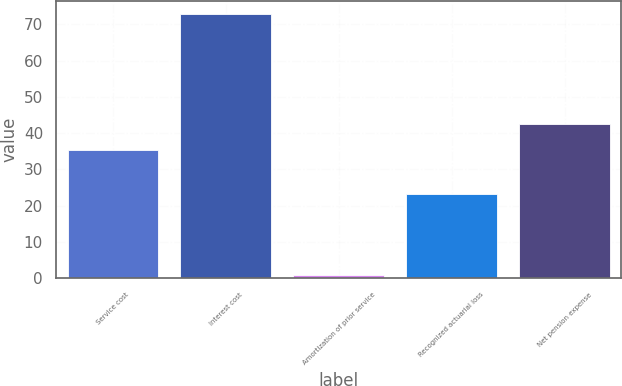Convert chart. <chart><loc_0><loc_0><loc_500><loc_500><bar_chart><fcel>Service cost<fcel>Interest cost<fcel>Amortization of prior service<fcel>Recognized actuarial loss<fcel>Net pension expense<nl><fcel>35.3<fcel>72.9<fcel>1<fcel>23.2<fcel>42.49<nl></chart> 